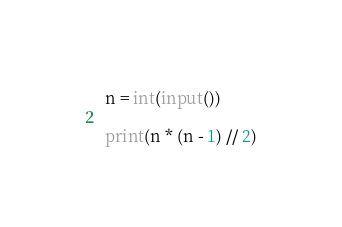<code> <loc_0><loc_0><loc_500><loc_500><_Python_>n = int(input())

print(n * (n - 1) // 2)</code> 